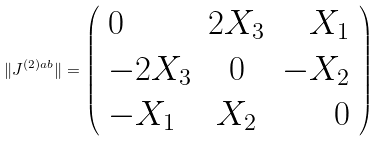Convert formula to latex. <formula><loc_0><loc_0><loc_500><loc_500>\| J ^ { ( 2 ) a b } \| = \left ( \begin{array} { l c r } 0 & 2 X _ { 3 } & X _ { 1 } \\ - 2 X _ { 3 } & 0 & - X _ { 2 } \\ - X _ { 1 } & X _ { 2 } & 0 \end{array} \right )</formula> 